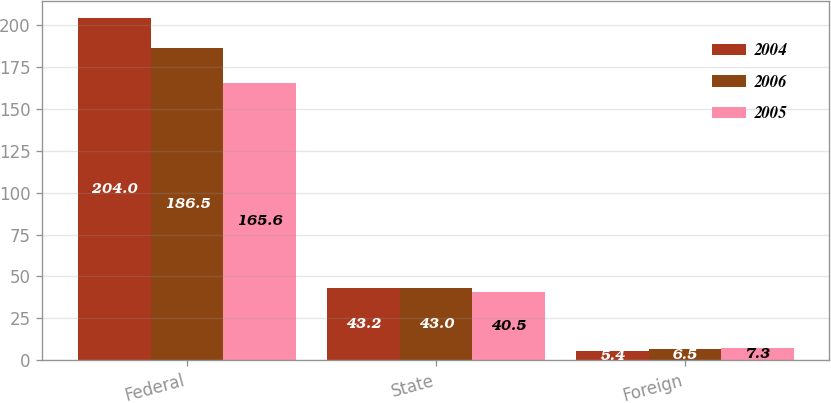Convert chart. <chart><loc_0><loc_0><loc_500><loc_500><stacked_bar_chart><ecel><fcel>Federal<fcel>State<fcel>Foreign<nl><fcel>2004<fcel>204<fcel>43.2<fcel>5.4<nl><fcel>2006<fcel>186.5<fcel>43<fcel>6.5<nl><fcel>2005<fcel>165.6<fcel>40.5<fcel>7.3<nl></chart> 